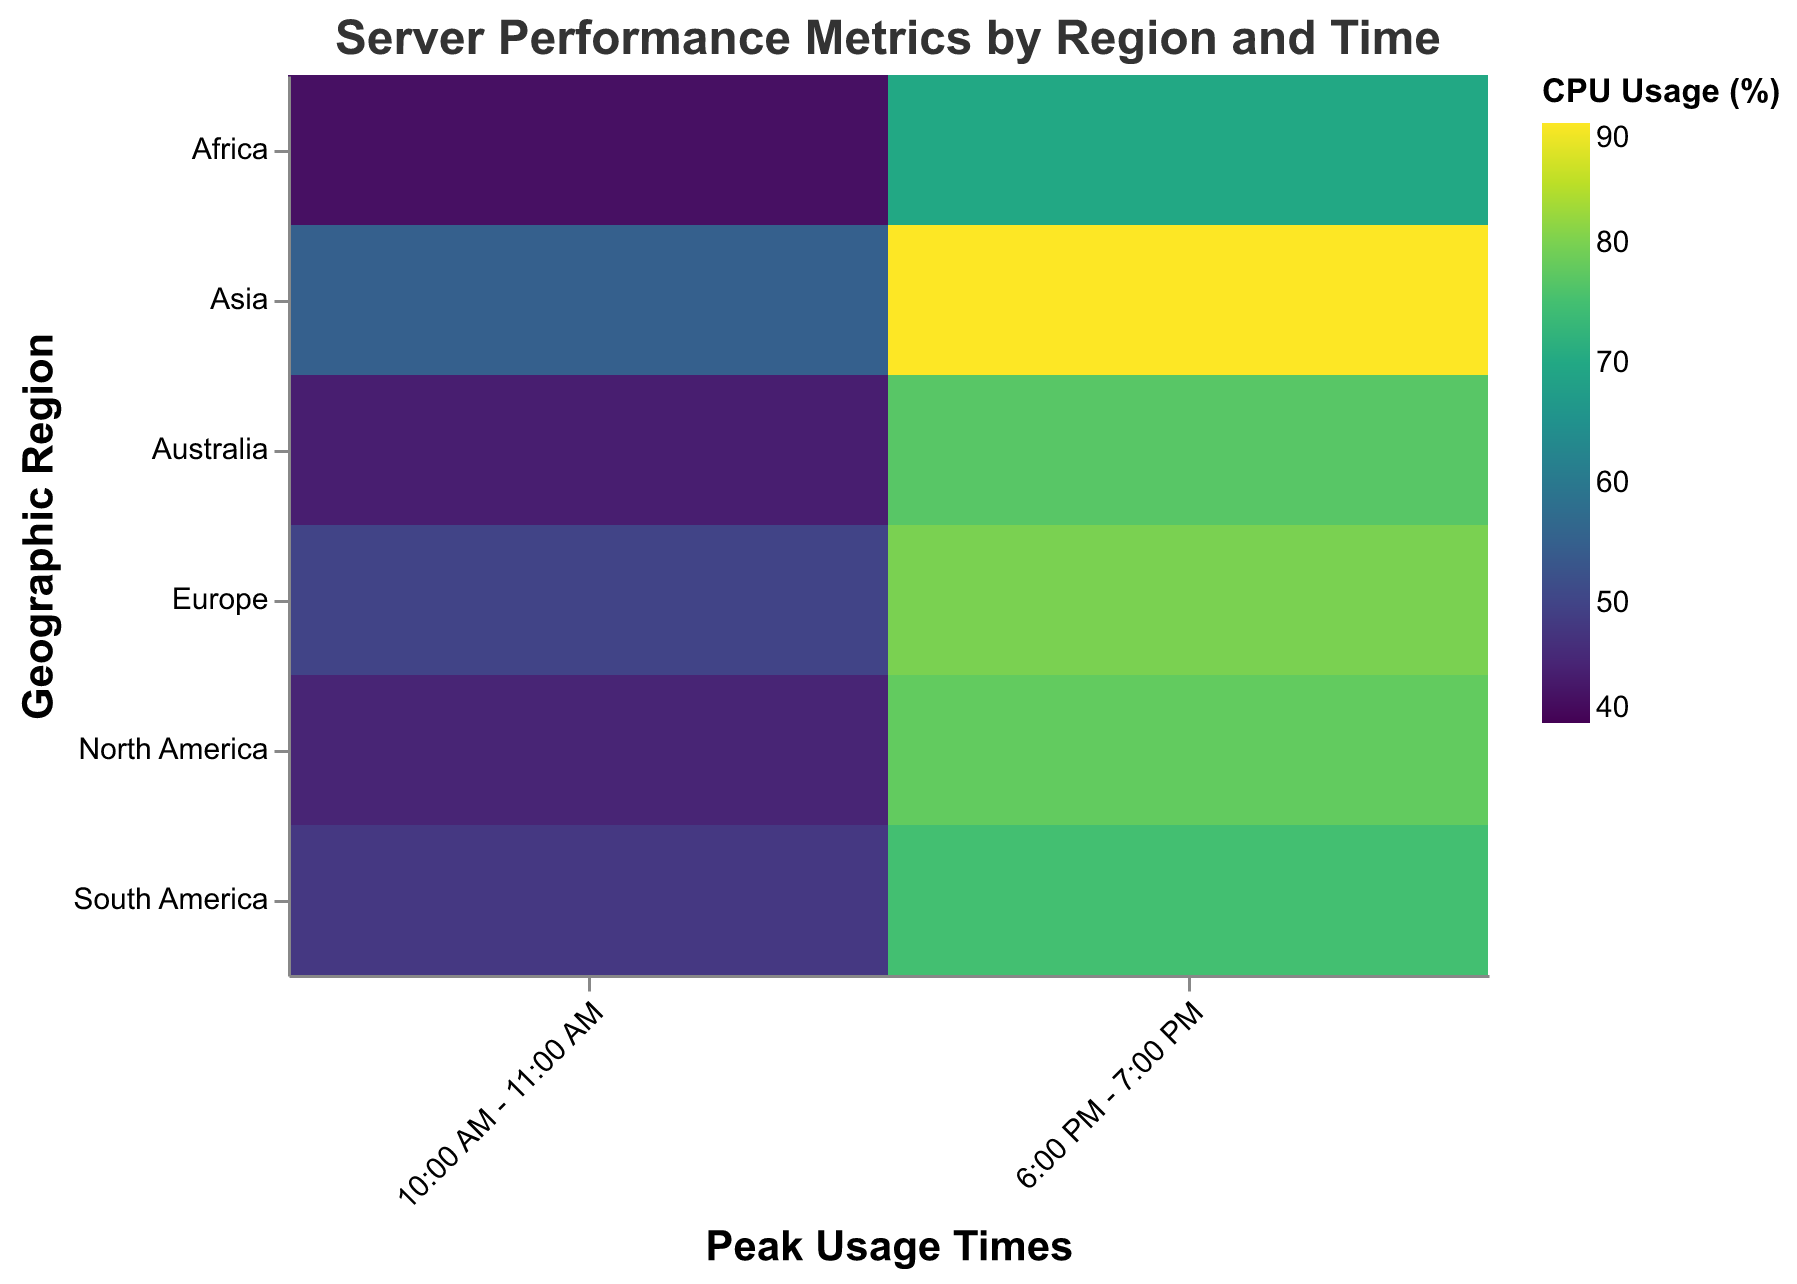What is the title of the heatmap? The title of the heatmap is usually displayed prominently at the top of the figure with a larger font size. In this heatmap, the title is given as "Server Performance Metrics by Region and Time" in the provided code.
Answer: Server Performance Metrics by Region and Time Which geographic region and peak usage time combination has the highest CPU usage? We can identify the highest CPU usage by examining the heatmap and looking for the darkest or most intense color according to the color scale provided. From the data values, the highest CPU usage is 90%, which occurs in Asia between 6:00 PM and 7:00 PM.
Answer: Asia, 6:00 PM - 7:00 PM How does the network latency in Europe between 10:00 AM and 11:00 AM compare to that in Africa at the same time? To compare the network latency, we look for the corresponding regions and times on the heatmap and check the tooltip or color intensity. According to the provided data, Europe has 45 ms of latency and Africa has 60 ms at 10:00 AM - 11:00 AM. Therefore, Europe's latency is lower.
Answer: Europe has lower latency What is the average CPU usage across all regions during 10:00 AM - 11:00 AM? To find the average CPU usage, we sum the CPU usage percentages for all regions at 10:00 AM - 11:00 AM and divide by the number of regions. The values are: 45, 50, 55, 48, 42, and 44. The sum is 284, and there are 6 regions. Therefore, the average is 284 / 6.
Answer: 47.33% Which region has the least variability in CPU usage between 10:00 AM - 11:00 AM and 6:00 PM - 7:00 PM? Variability can be assessed by calculating the difference in CPU usage at the two times for each region and finding the smallest difference. From the data:
North America: 78 - 45 = 33
Europe: 80 - 50 = 30
Asia: 90 - 55 = 35
South America: 75 - 48 = 27
Africa: 70 - 42 = 28
Australia: 77 - 44 = 33
The smallest difference is 27 in South America.
Answer: South America Is there a region where the network latency is consistently above 60 ms at both peak usage times? We need to look at the network latency values for each region at both times and check if both values are above 60 ms. According to the data provided:
North America: 50, 62
Europe: 45, 70
Asia: 40, 82
South America: 55, 68
Africa: 60, 75
Australia: 45, 65
Africa is the only region with network latency consistently above 60 ms at both times.
Answer: Africa 